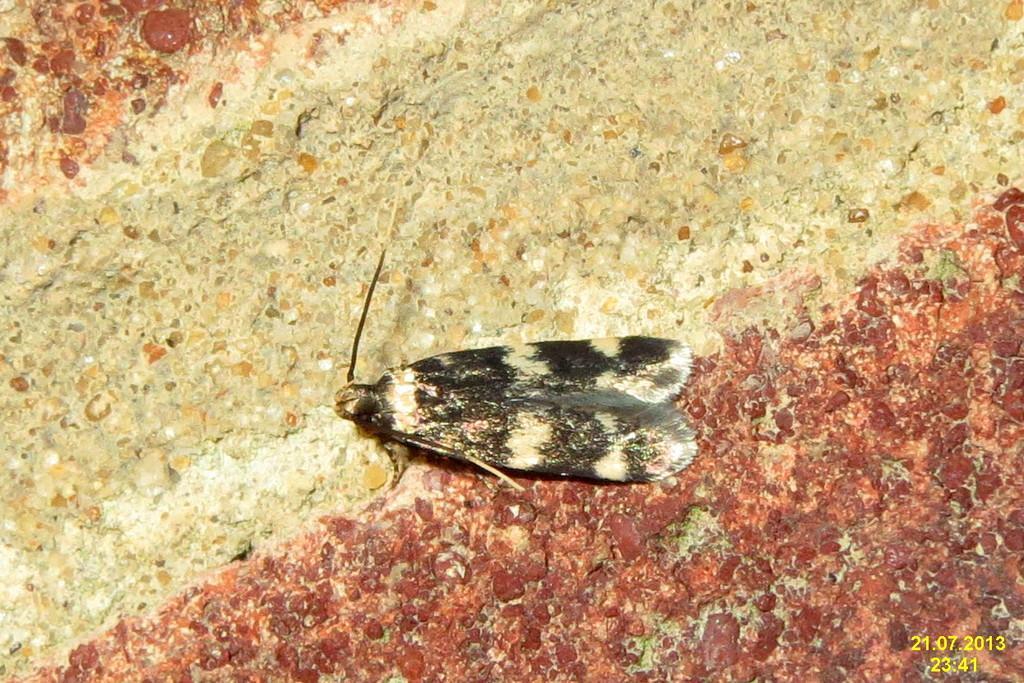Can you describe this image briefly? In this picture we can see an insect sitting on a red white floor. 